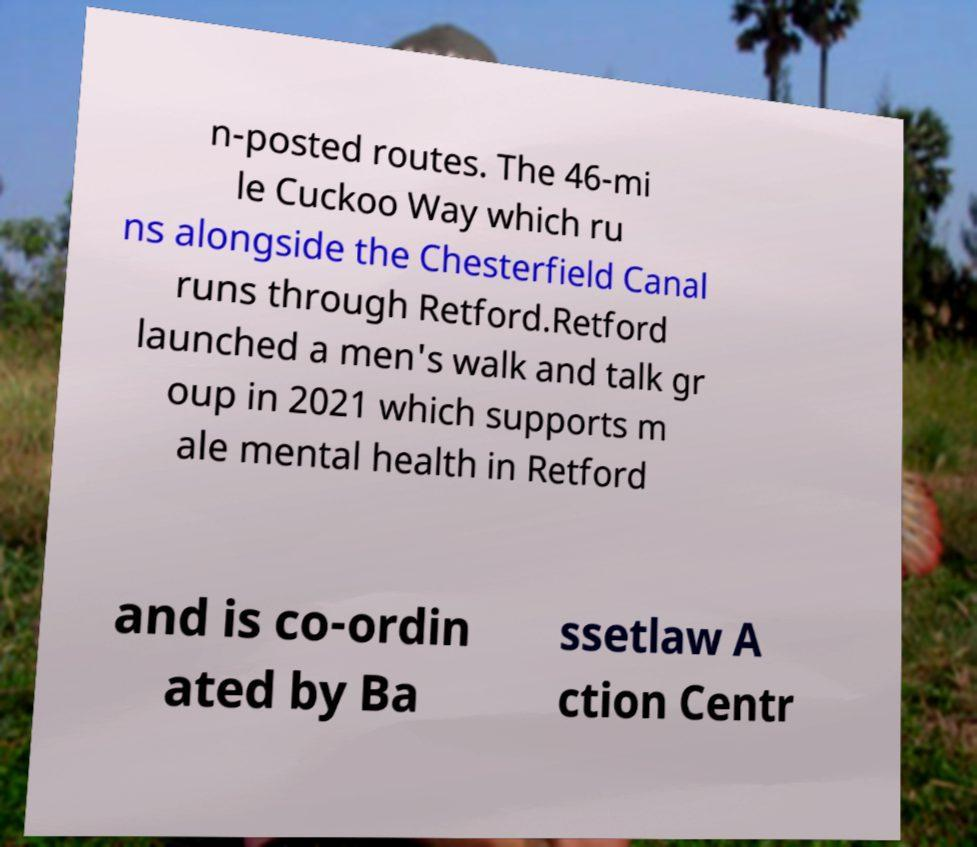I need the written content from this picture converted into text. Can you do that? n-posted routes. The 46-mi le Cuckoo Way which ru ns alongside the Chesterfield Canal runs through Retford.Retford launched a men's walk and talk gr oup in 2021 which supports m ale mental health in Retford and is co-ordin ated by Ba ssetlaw A ction Centr 